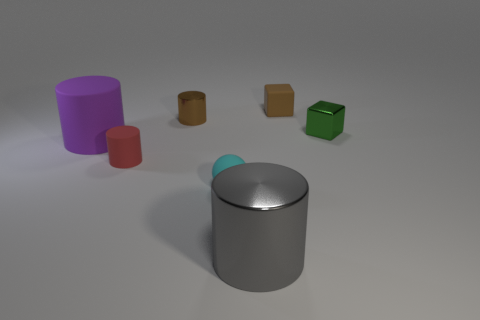Subtract all yellow cylinders. Subtract all gray balls. How many cylinders are left? 4 Add 1 big gray cylinders. How many objects exist? 8 Subtract all cylinders. How many objects are left? 3 Subtract all large metallic cylinders. Subtract all small cyan matte things. How many objects are left? 5 Add 6 shiny objects. How many shiny objects are left? 9 Add 6 big blue rubber balls. How many big blue rubber balls exist? 6 Subtract 0 gray cubes. How many objects are left? 7 